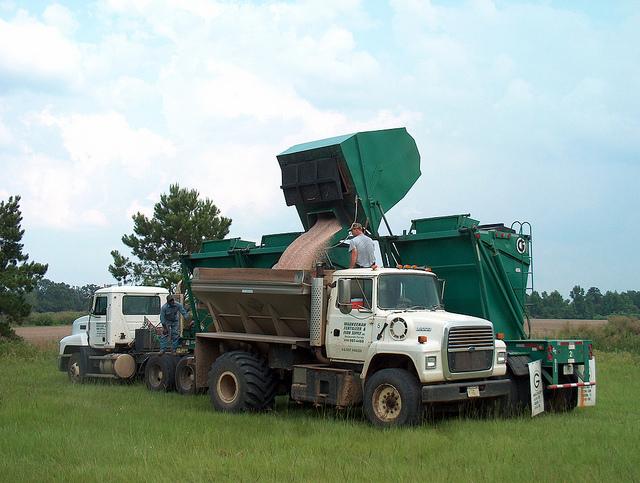Is it cloudy?
Short answer required. Yes. How many trucks are there?
Give a very brief answer. 2. What color is the tallest truck?
Short answer required. Green. How many people are in the picture?
Short answer required. 2. Is there a shadow near the truck?
Keep it brief. No. Is this a landscaping truck?
Write a very short answer. Yes. Have the trucks been lifted?
Quick response, please. No. 